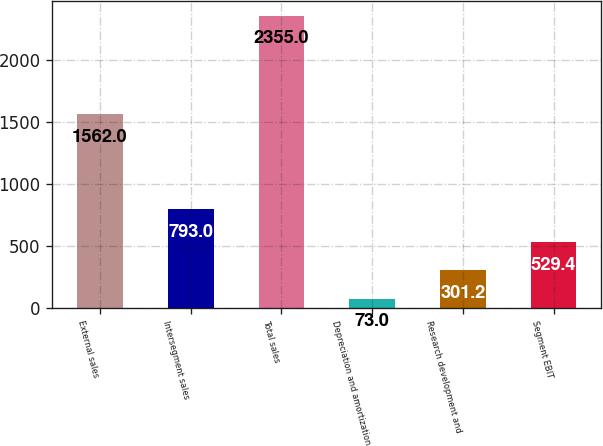<chart> <loc_0><loc_0><loc_500><loc_500><bar_chart><fcel>External sales<fcel>Intersegment sales<fcel>Total sales<fcel>Depreciation and amortization<fcel>Research development and<fcel>Segment EBIT<nl><fcel>1562<fcel>793<fcel>2355<fcel>73<fcel>301.2<fcel>529.4<nl></chart> 